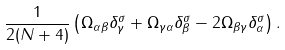<formula> <loc_0><loc_0><loc_500><loc_500>\frac { 1 } { 2 ( N + 4 ) } \left ( \Omega _ { \alpha \beta } \delta _ { \gamma } ^ { \sigma } + \Omega _ { \gamma \alpha } \delta _ { \beta } ^ { \sigma } - 2 \Omega _ { \beta \gamma } \delta _ { \alpha } ^ { \sigma } \right ) .</formula> 